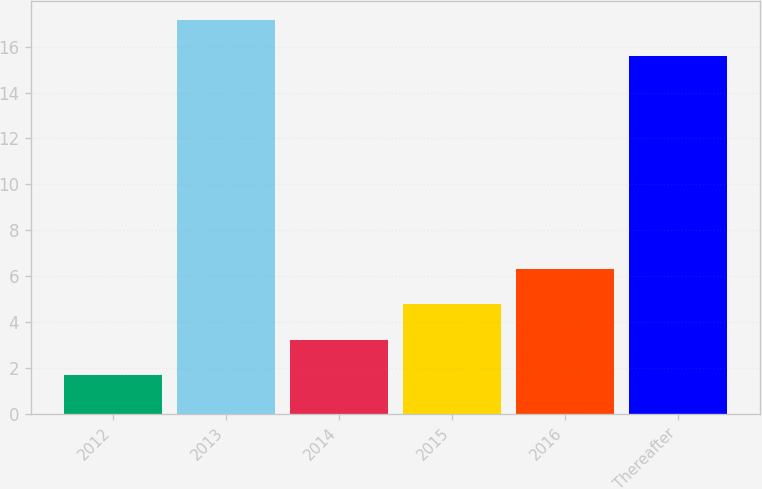<chart> <loc_0><loc_0><loc_500><loc_500><bar_chart><fcel>2012<fcel>2013<fcel>2014<fcel>2015<fcel>2016<fcel>Thereafter<nl><fcel>1.7<fcel>17.14<fcel>3.24<fcel>4.78<fcel>6.32<fcel>15.6<nl></chart> 